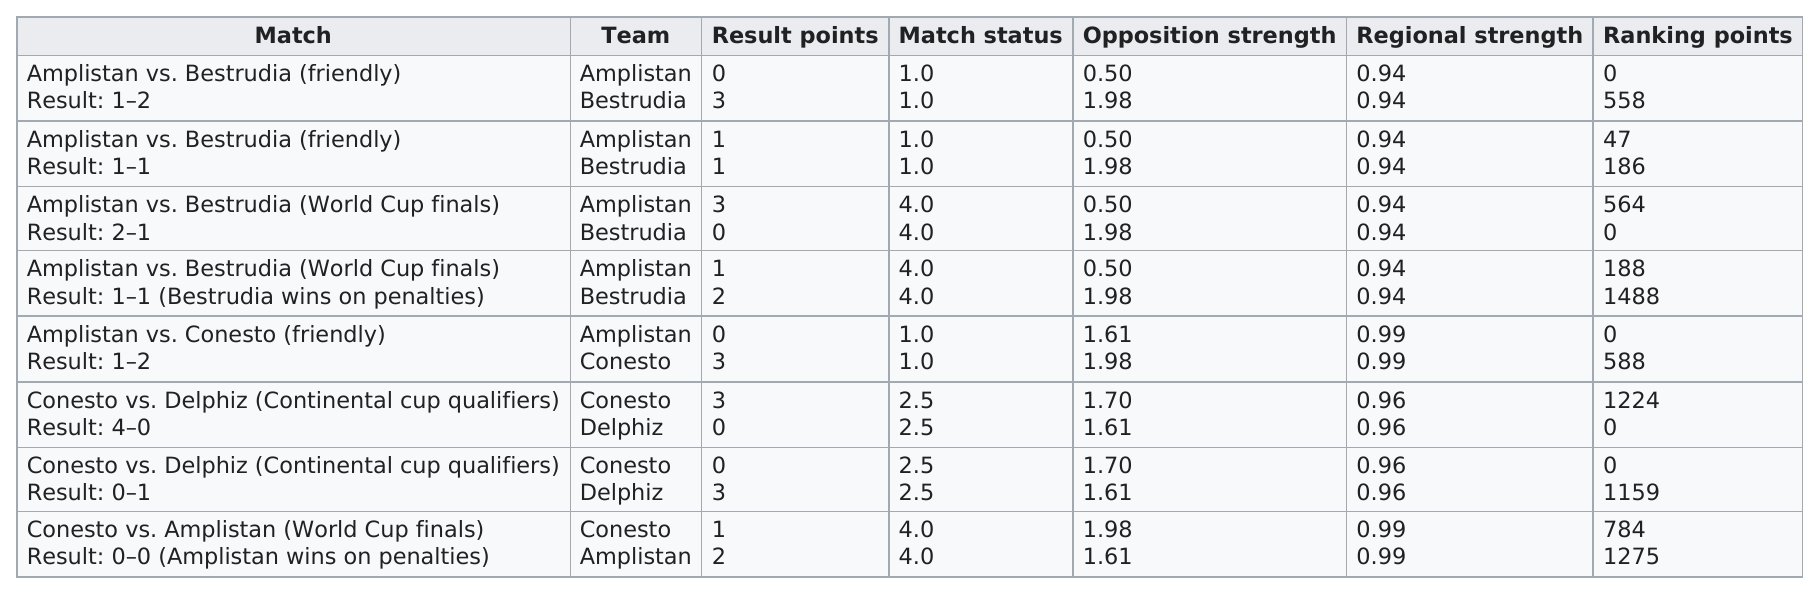Indicate a few pertinent items in this graphic. In the final match of the World Cup, Conesto competed against Amplistan. In a friendly match between Amplistan and Bestrudia, the teams had a regional strength of 0.94 each. The final score was 1-2 in favor of Amplistan. The total number of matches on the chart is 8. Amplistan's team scored the least against the opposition's strength, making them a formidable force to be reckoned with. The difference in opposition strength between "Amplistan" and "Bestrudia" is 1.48. 